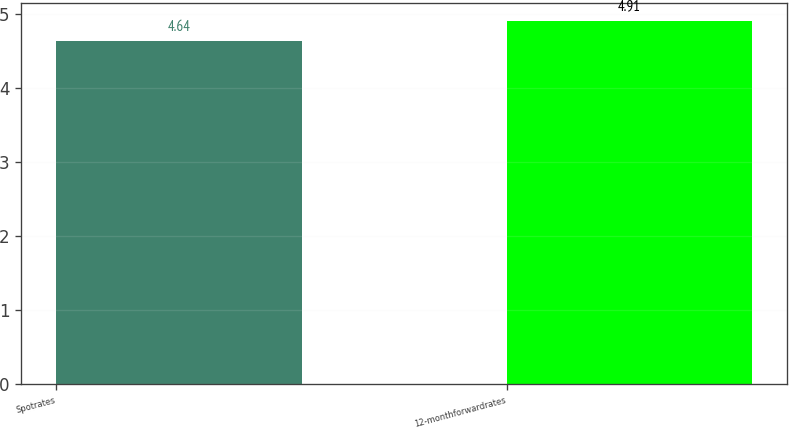Convert chart to OTSL. <chart><loc_0><loc_0><loc_500><loc_500><bar_chart><fcel>Spotrates<fcel>12-monthforwardrates<nl><fcel>4.64<fcel>4.91<nl></chart> 